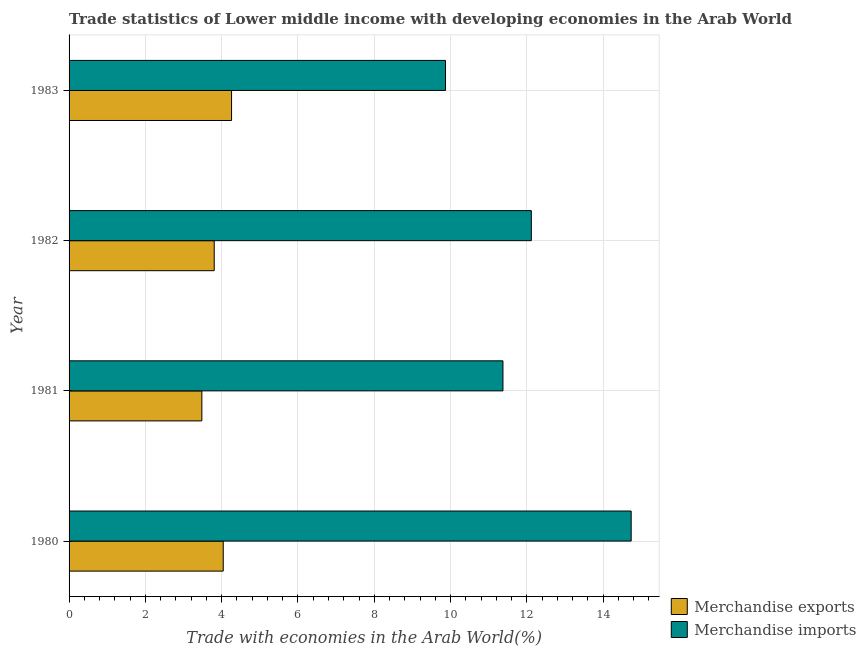How many bars are there on the 2nd tick from the top?
Offer a very short reply. 2. What is the label of the 1st group of bars from the top?
Give a very brief answer. 1983. What is the merchandise imports in 1980?
Your answer should be very brief. 14.73. Across all years, what is the maximum merchandise imports?
Keep it short and to the point. 14.73. Across all years, what is the minimum merchandise exports?
Offer a terse response. 3.48. In which year was the merchandise imports maximum?
Your answer should be very brief. 1980. In which year was the merchandise exports minimum?
Your answer should be very brief. 1981. What is the total merchandise exports in the graph?
Keep it short and to the point. 15.59. What is the difference between the merchandise imports in 1980 and that in 1981?
Your response must be concise. 3.36. What is the difference between the merchandise imports in 1980 and the merchandise exports in 1983?
Your answer should be very brief. 10.47. What is the average merchandise exports per year?
Ensure brevity in your answer.  3.9. In the year 1980, what is the difference between the merchandise imports and merchandise exports?
Keep it short and to the point. 10.69. In how many years, is the merchandise exports greater than 4 %?
Your answer should be compact. 2. What is the ratio of the merchandise imports in 1980 to that in 1981?
Give a very brief answer. 1.29. Is the merchandise imports in 1980 less than that in 1982?
Your answer should be compact. No. Is the difference between the merchandise exports in 1981 and 1982 greater than the difference between the merchandise imports in 1981 and 1982?
Provide a short and direct response. Yes. What is the difference between the highest and the second highest merchandise imports?
Provide a succinct answer. 2.62. What is the difference between the highest and the lowest merchandise imports?
Your response must be concise. 4.87. In how many years, is the merchandise exports greater than the average merchandise exports taken over all years?
Keep it short and to the point. 2. What does the 2nd bar from the bottom in 1983 represents?
Ensure brevity in your answer.  Merchandise imports. Are all the bars in the graph horizontal?
Your response must be concise. Yes. Are the values on the major ticks of X-axis written in scientific E-notation?
Offer a very short reply. No. What is the title of the graph?
Offer a terse response. Trade statistics of Lower middle income with developing economies in the Arab World. What is the label or title of the X-axis?
Your answer should be very brief. Trade with economies in the Arab World(%). What is the Trade with economies in the Arab World(%) of Merchandise exports in 1980?
Your answer should be very brief. 4.04. What is the Trade with economies in the Arab World(%) in Merchandise imports in 1980?
Your answer should be very brief. 14.73. What is the Trade with economies in the Arab World(%) in Merchandise exports in 1981?
Your answer should be compact. 3.48. What is the Trade with economies in the Arab World(%) in Merchandise imports in 1981?
Give a very brief answer. 11.37. What is the Trade with economies in the Arab World(%) of Merchandise exports in 1982?
Make the answer very short. 3.8. What is the Trade with economies in the Arab World(%) of Merchandise imports in 1982?
Provide a short and direct response. 12.12. What is the Trade with economies in the Arab World(%) of Merchandise exports in 1983?
Your answer should be very brief. 4.26. What is the Trade with economies in the Arab World(%) in Merchandise imports in 1983?
Your answer should be compact. 9.87. Across all years, what is the maximum Trade with economies in the Arab World(%) in Merchandise exports?
Provide a short and direct response. 4.26. Across all years, what is the maximum Trade with economies in the Arab World(%) of Merchandise imports?
Make the answer very short. 14.73. Across all years, what is the minimum Trade with economies in the Arab World(%) in Merchandise exports?
Your answer should be very brief. 3.48. Across all years, what is the minimum Trade with economies in the Arab World(%) in Merchandise imports?
Provide a short and direct response. 9.87. What is the total Trade with economies in the Arab World(%) in Merchandise exports in the graph?
Ensure brevity in your answer.  15.59. What is the total Trade with economies in the Arab World(%) of Merchandise imports in the graph?
Provide a succinct answer. 48.09. What is the difference between the Trade with economies in the Arab World(%) in Merchandise exports in 1980 and that in 1981?
Your response must be concise. 0.56. What is the difference between the Trade with economies in the Arab World(%) of Merchandise imports in 1980 and that in 1981?
Provide a succinct answer. 3.36. What is the difference between the Trade with economies in the Arab World(%) in Merchandise exports in 1980 and that in 1982?
Provide a succinct answer. 0.24. What is the difference between the Trade with economies in the Arab World(%) of Merchandise imports in 1980 and that in 1982?
Ensure brevity in your answer.  2.62. What is the difference between the Trade with economies in the Arab World(%) of Merchandise exports in 1980 and that in 1983?
Your answer should be compact. -0.22. What is the difference between the Trade with economies in the Arab World(%) in Merchandise imports in 1980 and that in 1983?
Ensure brevity in your answer.  4.87. What is the difference between the Trade with economies in the Arab World(%) of Merchandise exports in 1981 and that in 1982?
Your answer should be compact. -0.32. What is the difference between the Trade with economies in the Arab World(%) in Merchandise imports in 1981 and that in 1982?
Provide a succinct answer. -0.74. What is the difference between the Trade with economies in the Arab World(%) in Merchandise exports in 1981 and that in 1983?
Make the answer very short. -0.78. What is the difference between the Trade with economies in the Arab World(%) in Merchandise imports in 1981 and that in 1983?
Provide a short and direct response. 1.51. What is the difference between the Trade with economies in the Arab World(%) in Merchandise exports in 1982 and that in 1983?
Provide a succinct answer. -0.45. What is the difference between the Trade with economies in the Arab World(%) in Merchandise imports in 1982 and that in 1983?
Offer a very short reply. 2.25. What is the difference between the Trade with economies in the Arab World(%) in Merchandise exports in 1980 and the Trade with economies in the Arab World(%) in Merchandise imports in 1981?
Ensure brevity in your answer.  -7.33. What is the difference between the Trade with economies in the Arab World(%) in Merchandise exports in 1980 and the Trade with economies in the Arab World(%) in Merchandise imports in 1982?
Give a very brief answer. -8.08. What is the difference between the Trade with economies in the Arab World(%) in Merchandise exports in 1980 and the Trade with economies in the Arab World(%) in Merchandise imports in 1983?
Offer a very short reply. -5.83. What is the difference between the Trade with economies in the Arab World(%) of Merchandise exports in 1981 and the Trade with economies in the Arab World(%) of Merchandise imports in 1982?
Your response must be concise. -8.64. What is the difference between the Trade with economies in the Arab World(%) of Merchandise exports in 1981 and the Trade with economies in the Arab World(%) of Merchandise imports in 1983?
Your response must be concise. -6.39. What is the difference between the Trade with economies in the Arab World(%) of Merchandise exports in 1982 and the Trade with economies in the Arab World(%) of Merchandise imports in 1983?
Provide a short and direct response. -6.06. What is the average Trade with economies in the Arab World(%) of Merchandise exports per year?
Offer a very short reply. 3.9. What is the average Trade with economies in the Arab World(%) of Merchandise imports per year?
Your response must be concise. 12.02. In the year 1980, what is the difference between the Trade with economies in the Arab World(%) of Merchandise exports and Trade with economies in the Arab World(%) of Merchandise imports?
Offer a terse response. -10.69. In the year 1981, what is the difference between the Trade with economies in the Arab World(%) in Merchandise exports and Trade with economies in the Arab World(%) in Merchandise imports?
Offer a very short reply. -7.89. In the year 1982, what is the difference between the Trade with economies in the Arab World(%) in Merchandise exports and Trade with economies in the Arab World(%) in Merchandise imports?
Give a very brief answer. -8.31. In the year 1983, what is the difference between the Trade with economies in the Arab World(%) of Merchandise exports and Trade with economies in the Arab World(%) of Merchandise imports?
Offer a very short reply. -5.61. What is the ratio of the Trade with economies in the Arab World(%) of Merchandise exports in 1980 to that in 1981?
Ensure brevity in your answer.  1.16. What is the ratio of the Trade with economies in the Arab World(%) in Merchandise imports in 1980 to that in 1981?
Your answer should be very brief. 1.3. What is the ratio of the Trade with economies in the Arab World(%) of Merchandise exports in 1980 to that in 1982?
Make the answer very short. 1.06. What is the ratio of the Trade with economies in the Arab World(%) of Merchandise imports in 1980 to that in 1982?
Keep it short and to the point. 1.22. What is the ratio of the Trade with economies in the Arab World(%) of Merchandise exports in 1980 to that in 1983?
Offer a terse response. 0.95. What is the ratio of the Trade with economies in the Arab World(%) in Merchandise imports in 1980 to that in 1983?
Your answer should be compact. 1.49. What is the ratio of the Trade with economies in the Arab World(%) in Merchandise exports in 1981 to that in 1982?
Provide a succinct answer. 0.91. What is the ratio of the Trade with economies in the Arab World(%) of Merchandise imports in 1981 to that in 1982?
Provide a short and direct response. 0.94. What is the ratio of the Trade with economies in the Arab World(%) of Merchandise exports in 1981 to that in 1983?
Provide a succinct answer. 0.82. What is the ratio of the Trade with economies in the Arab World(%) in Merchandise imports in 1981 to that in 1983?
Make the answer very short. 1.15. What is the ratio of the Trade with economies in the Arab World(%) of Merchandise exports in 1982 to that in 1983?
Make the answer very short. 0.89. What is the ratio of the Trade with economies in the Arab World(%) of Merchandise imports in 1982 to that in 1983?
Offer a very short reply. 1.23. What is the difference between the highest and the second highest Trade with economies in the Arab World(%) of Merchandise exports?
Offer a terse response. 0.22. What is the difference between the highest and the second highest Trade with economies in the Arab World(%) of Merchandise imports?
Your answer should be very brief. 2.62. What is the difference between the highest and the lowest Trade with economies in the Arab World(%) in Merchandise exports?
Keep it short and to the point. 0.78. What is the difference between the highest and the lowest Trade with economies in the Arab World(%) in Merchandise imports?
Provide a short and direct response. 4.87. 